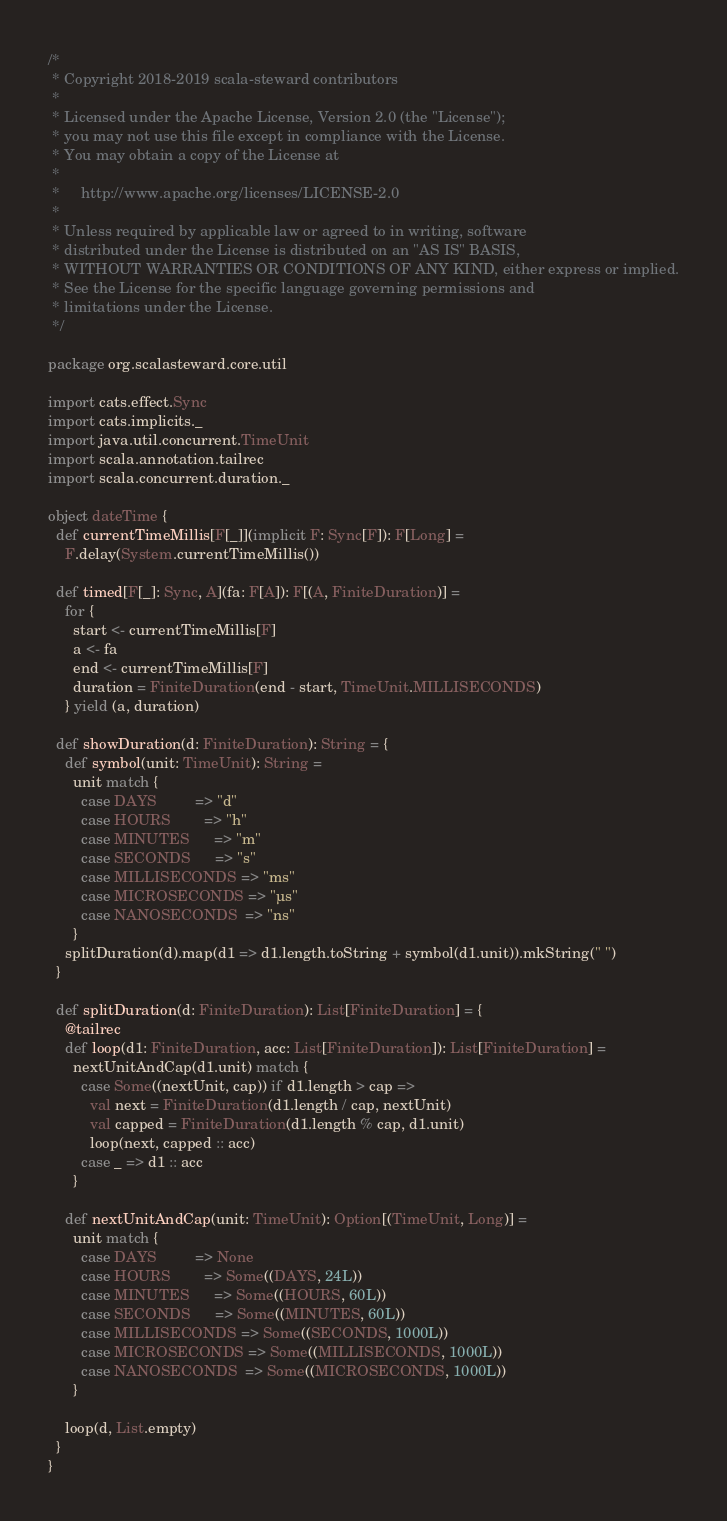Convert code to text. <code><loc_0><loc_0><loc_500><loc_500><_Scala_>/*
 * Copyright 2018-2019 scala-steward contributors
 *
 * Licensed under the Apache License, Version 2.0 (the "License");
 * you may not use this file except in compliance with the License.
 * You may obtain a copy of the License at
 *
 *     http://www.apache.org/licenses/LICENSE-2.0
 *
 * Unless required by applicable law or agreed to in writing, software
 * distributed under the License is distributed on an "AS IS" BASIS,
 * WITHOUT WARRANTIES OR CONDITIONS OF ANY KIND, either express or implied.
 * See the License for the specific language governing permissions and
 * limitations under the License.
 */

package org.scalasteward.core.util

import cats.effect.Sync
import cats.implicits._
import java.util.concurrent.TimeUnit
import scala.annotation.tailrec
import scala.concurrent.duration._

object dateTime {
  def currentTimeMillis[F[_]](implicit F: Sync[F]): F[Long] =
    F.delay(System.currentTimeMillis())

  def timed[F[_]: Sync, A](fa: F[A]): F[(A, FiniteDuration)] =
    for {
      start <- currentTimeMillis[F]
      a <- fa
      end <- currentTimeMillis[F]
      duration = FiniteDuration(end - start, TimeUnit.MILLISECONDS)
    } yield (a, duration)

  def showDuration(d: FiniteDuration): String = {
    def symbol(unit: TimeUnit): String =
      unit match {
        case DAYS         => "d"
        case HOURS        => "h"
        case MINUTES      => "m"
        case SECONDS      => "s"
        case MILLISECONDS => "ms"
        case MICROSECONDS => "µs"
        case NANOSECONDS  => "ns"
      }
    splitDuration(d).map(d1 => d1.length.toString + symbol(d1.unit)).mkString(" ")
  }

  def splitDuration(d: FiniteDuration): List[FiniteDuration] = {
    @tailrec
    def loop(d1: FiniteDuration, acc: List[FiniteDuration]): List[FiniteDuration] =
      nextUnitAndCap(d1.unit) match {
        case Some((nextUnit, cap)) if d1.length > cap =>
          val next = FiniteDuration(d1.length / cap, nextUnit)
          val capped = FiniteDuration(d1.length % cap, d1.unit)
          loop(next, capped :: acc)
        case _ => d1 :: acc
      }

    def nextUnitAndCap(unit: TimeUnit): Option[(TimeUnit, Long)] =
      unit match {
        case DAYS         => None
        case HOURS        => Some((DAYS, 24L))
        case MINUTES      => Some((HOURS, 60L))
        case SECONDS      => Some((MINUTES, 60L))
        case MILLISECONDS => Some((SECONDS, 1000L))
        case MICROSECONDS => Some((MILLISECONDS, 1000L))
        case NANOSECONDS  => Some((MICROSECONDS, 1000L))
      }

    loop(d, List.empty)
  }
}
</code> 